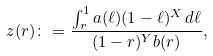Convert formula to latex. <formula><loc_0><loc_0><loc_500><loc_500>z ( r ) \colon = \frac { \int _ { r } ^ { 1 } a ( \ell ) ( 1 - \ell ) ^ { X } \, d \ell } { ( 1 - r ) ^ { Y } b ( r ) } ,</formula> 